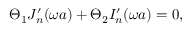<formula> <loc_0><loc_0><loc_500><loc_500>\Theta _ { 1 } J _ { n } ^ { \prime } ( \omega a ) + \Theta _ { 2 } I _ { n } ^ { \prime } ( \omega a ) = 0 ,</formula> 